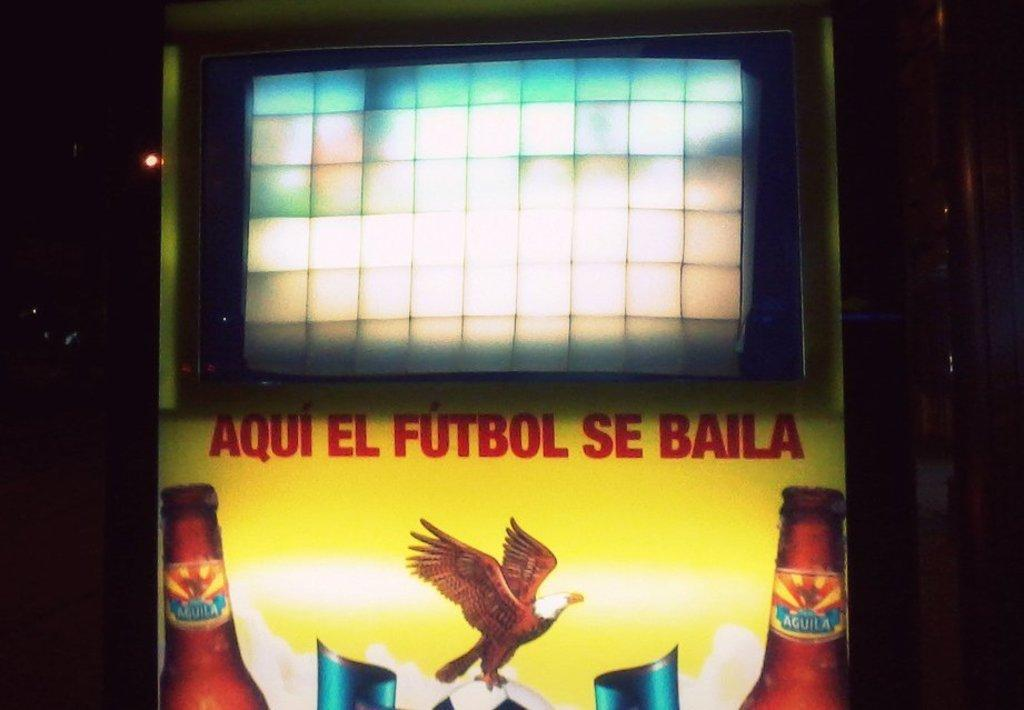<image>
Give a short and clear explanation of the subsequent image. The picture shows beer with the words Aqui El Futbol Se Baila. 